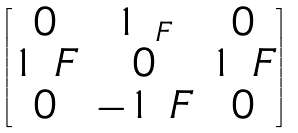<formula> <loc_0><loc_0><loc_500><loc_500>\begin{bmatrix} 0 & 1 _ { \ F } & 0 \\ 1 _ { \ } F & 0 & 1 _ { \ } F \\ 0 & - 1 _ { \ } F & 0 \end{bmatrix}</formula> 